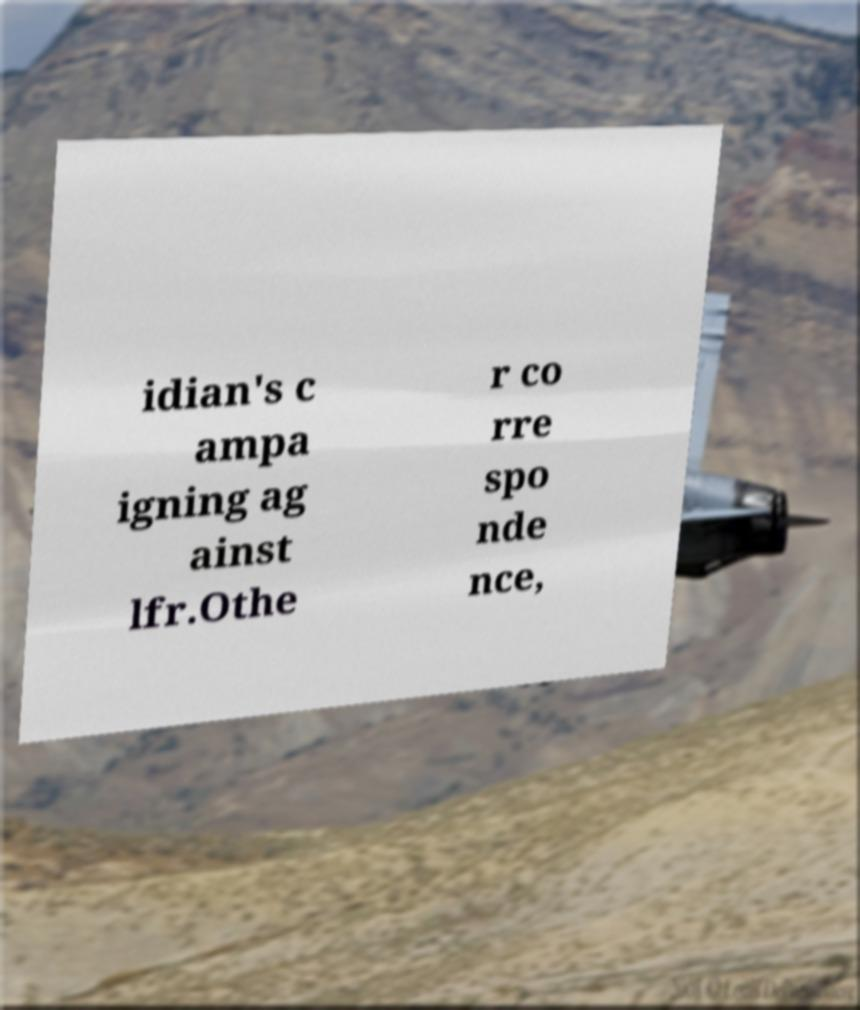Can you read and provide the text displayed in the image?This photo seems to have some interesting text. Can you extract and type it out for me? idian's c ampa igning ag ainst lfr.Othe r co rre spo nde nce, 